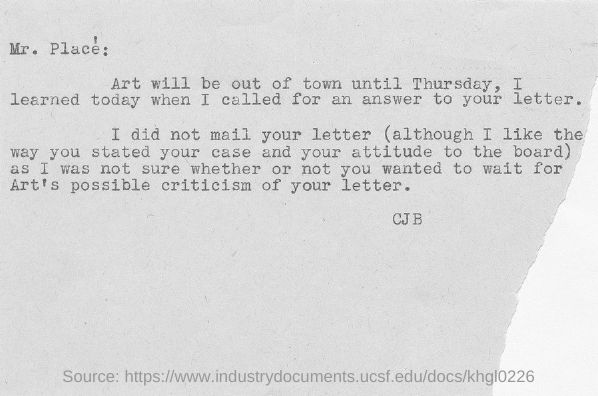List a handful of essential elements in this visual. The letter was written by CJB. 